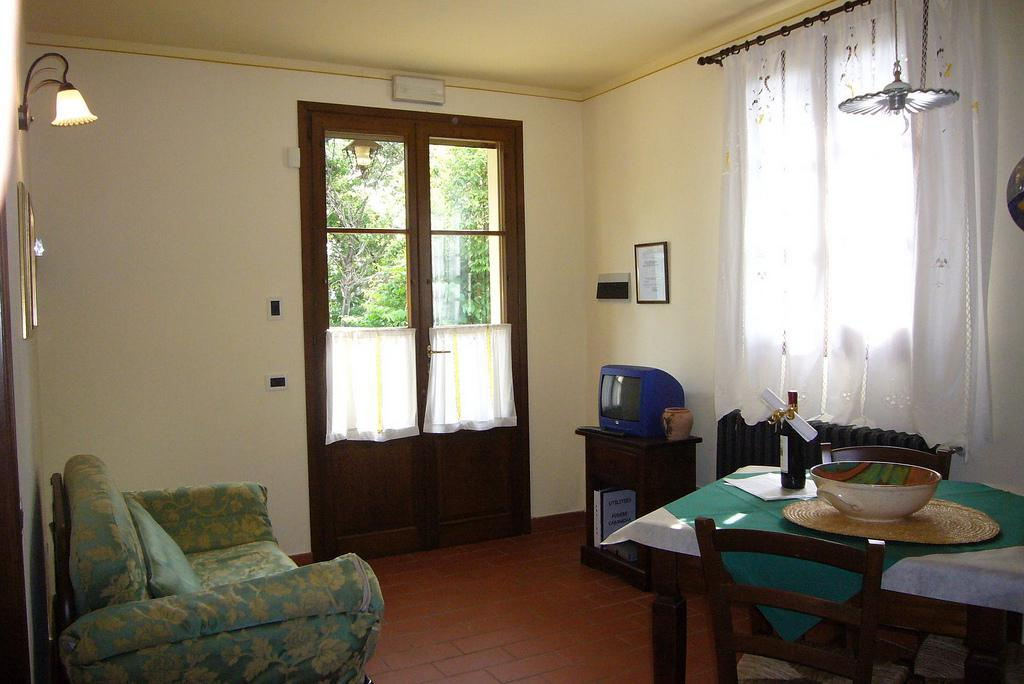Question: what is next to the fruit bowl?
Choices:
A. A cup of dip.
B. A bottle of wine.
C. A bowl of sugar.
D. A cup of tea.
Answer with the letter. Answer: B Question: how many lamps are there?
Choices:
A. Three.
B. Four.
C. Two.
D. One.
Answer with the letter. Answer: C Question: what season is it?
Choices:
A. Winter.
B. Spring.
C. Fall.
D. Summer.
Answer with the letter. Answer: D Question: what pattern decorates the blue chair?
Choices:
A. Swirls.
B. Yellow flowers.
C. Stripes.
D. Checkerboard.
Answer with the letter. Answer: B Question: what is on the wooden stand?
Choices:
A. A stack of books.
B. A pile of magazines.
C. A cup of water.
D. A small tv.
Answer with the letter. Answer: D Question: how is privacy maintained in the room?
Choices:
A. By shutters on the windows.
B. By closing the windows.
C. By curtains on the windows.
D. By covering the windows with a sheet.
Answer with the letter. Answer: C Question: why is the lamp glowing?
Choices:
A. The lightbulb is new.
B. The light is on.
C. It is dark in the room.
D. Someone is reading.
Answer with the letter. Answer: B Question: what is the table made of?
Choices:
A. Wood.
B. Plastic.
C. Metal.
D. Marble.
Answer with the letter. Answer: A Question: what is above the television?
Choices:
A. A vase of flowers.
B. A mirror.
C. A photograph.
D. A framed document.
Answer with the letter. Answer: D Question: what color are the curtains?
Choices:
A. White.
B. Brown.
C. Green.
D. Pink.
Answer with the letter. Answer: A Question: what is sitting on the wooden stand?
Choices:
A. A radio.
B. A mirror.
C. A picture in a frame.
D. A television.
Answer with the letter. Answer: D Question: what has wooden doors?
Choices:
A. Boats.
B. Trailers.
C. Shacks.
D. House.
Answer with the letter. Answer: D Question: what is out of the house?
Choices:
A. Trees.
B. Grass.
C. Garden.
D. Recycle bin.
Answer with the letter. Answer: A Question: what color is that mat at the table?
Choices:
A. Red.
B. Blue.
C. Grey.
D. The mat is green.
Answer with the letter. Answer: D 